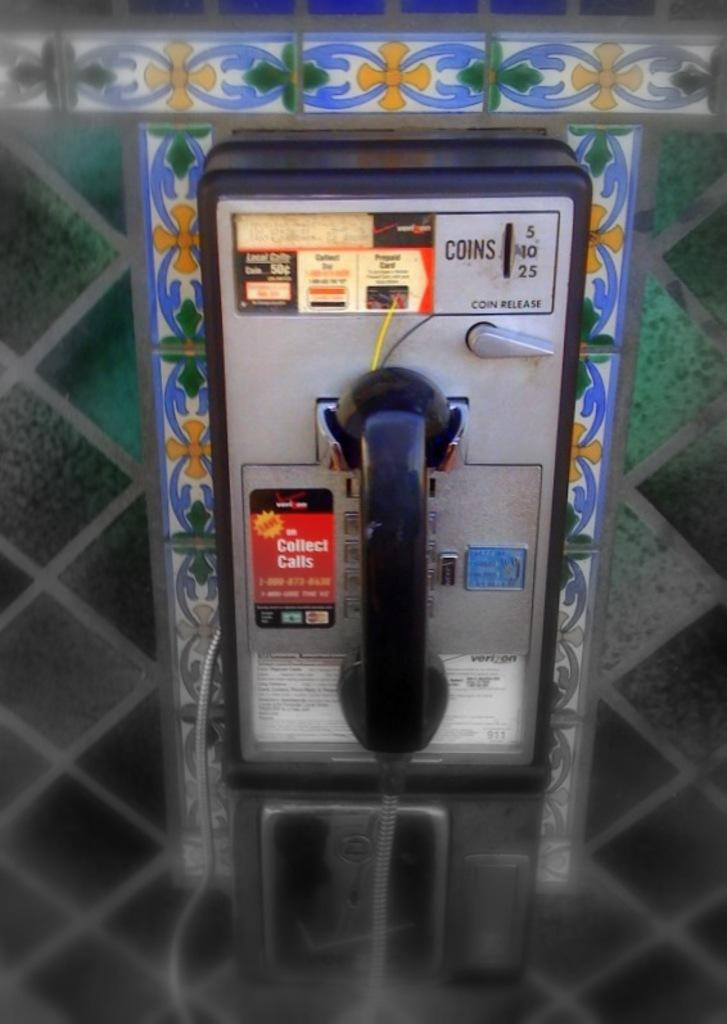<image>
Offer a succinct explanation of the picture presented. A pay phone with a sticker on it telling how to make collect calls. 